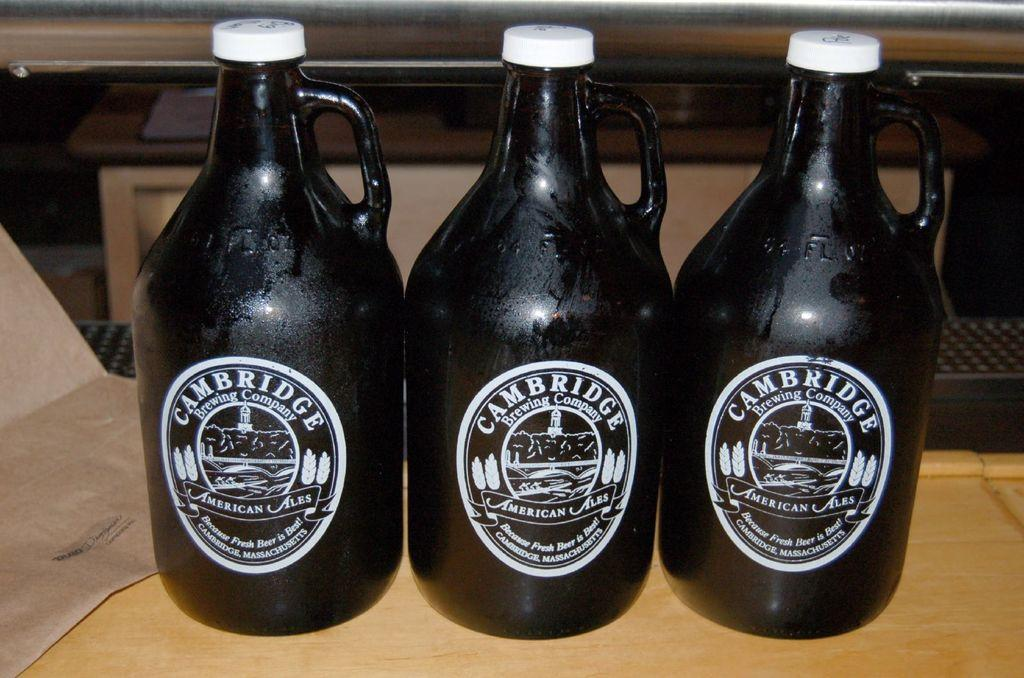<image>
Write a terse but informative summary of the picture. 3 jugs of Cambridge ale are lined up next to each other. 